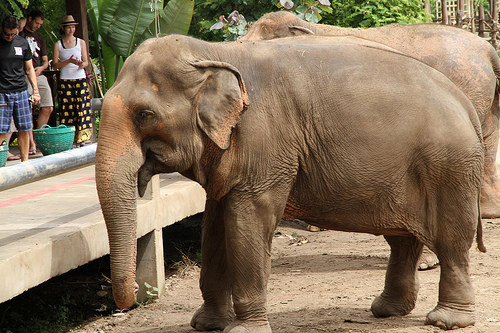Which side of the photo is the man on? The man is on the left side of the photo. 